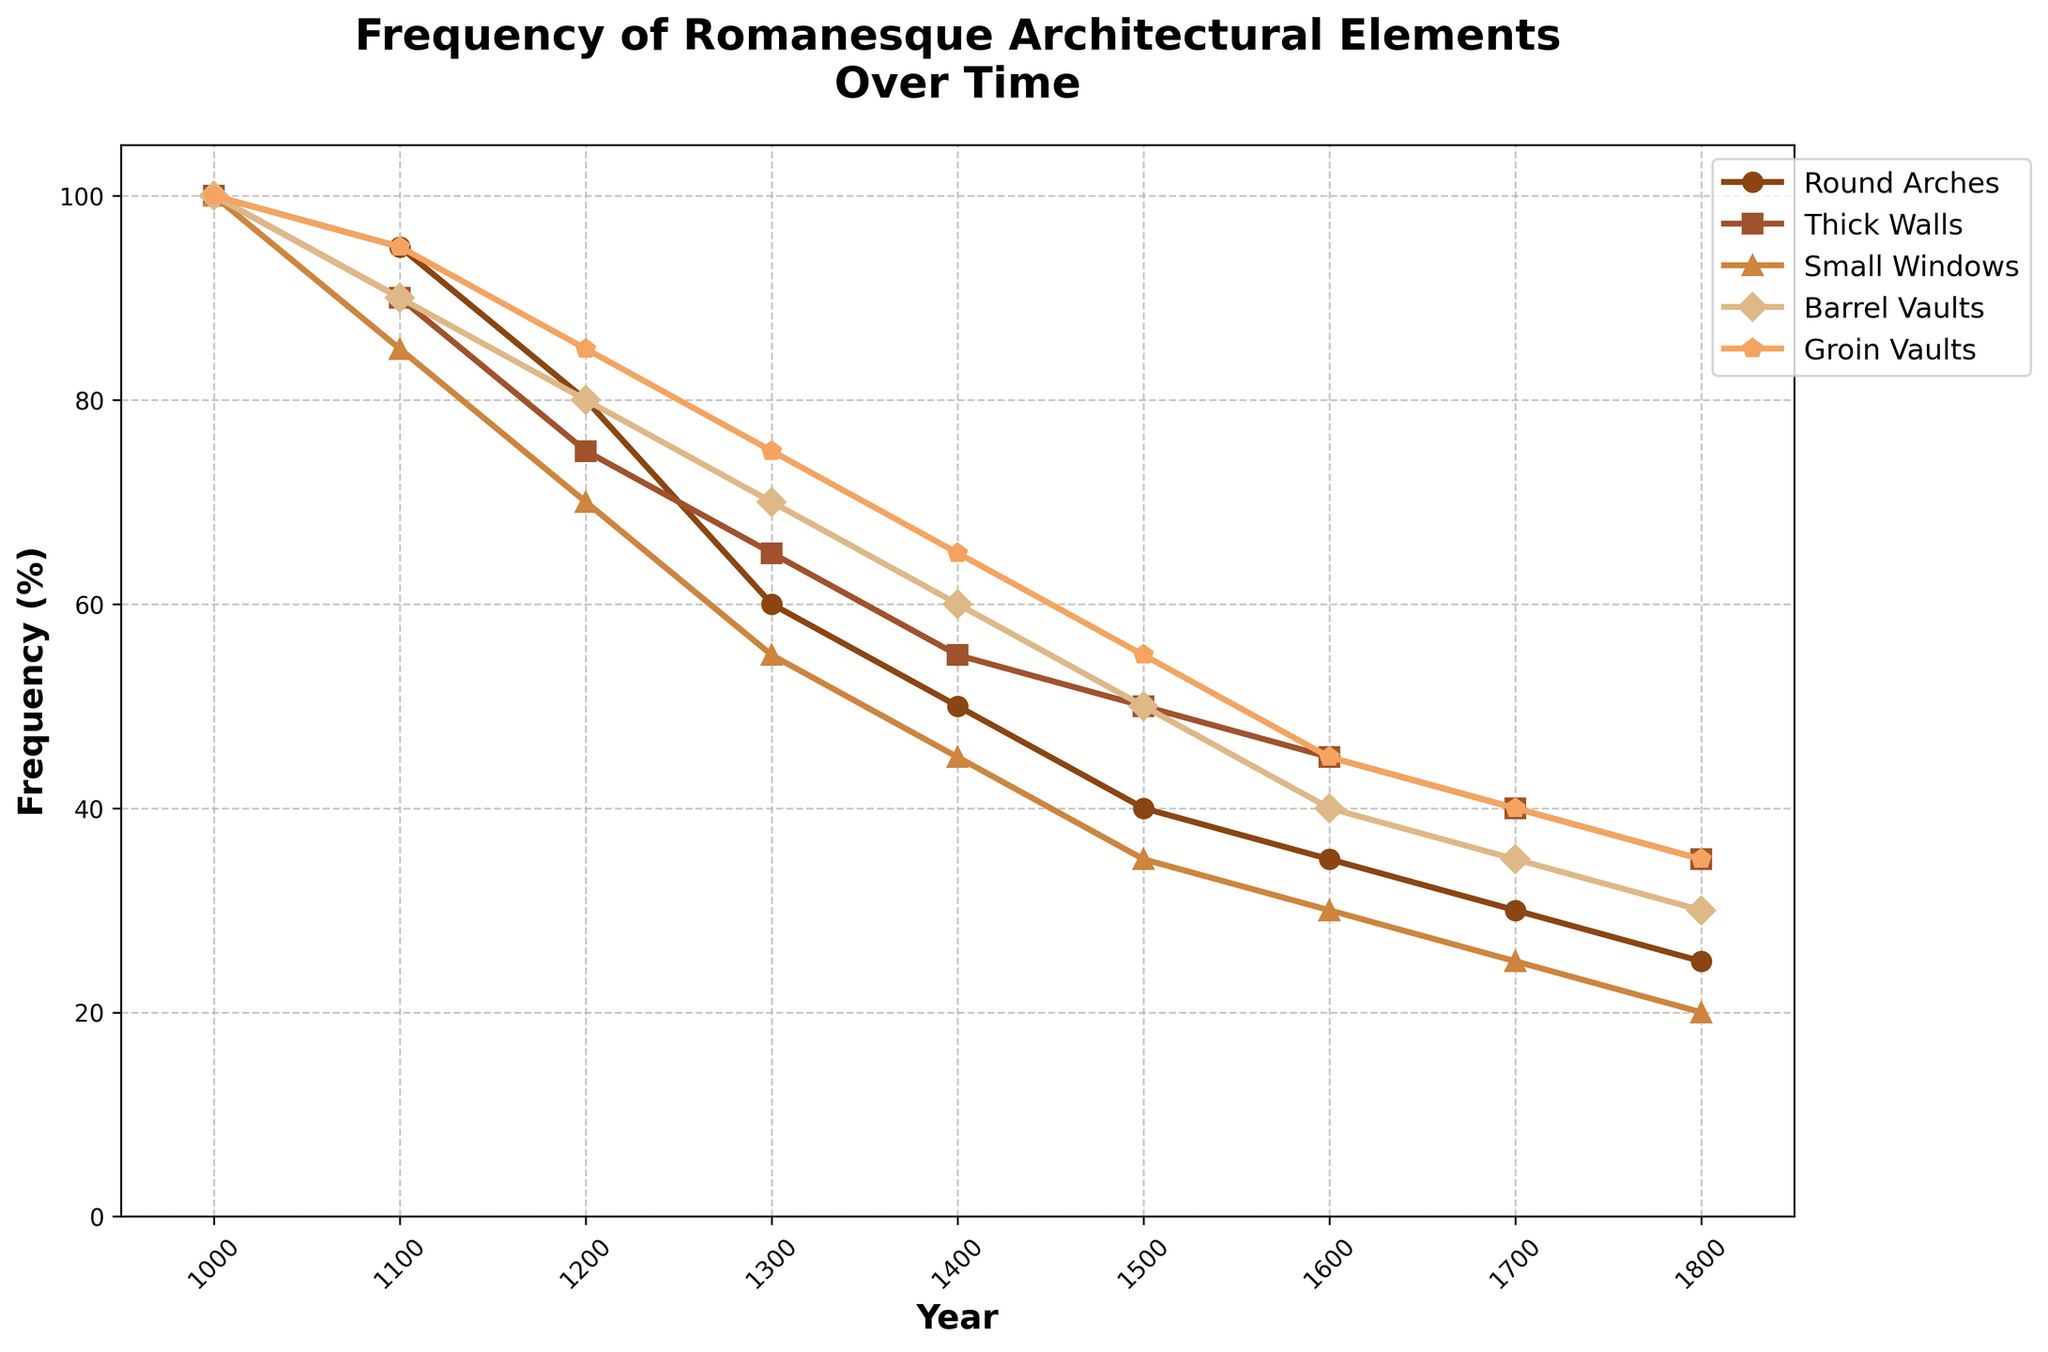What is the trend of the frequency of Round Arches from 1000 AD to 1800 AD? The frequency of Round Arches decreases steadily over time. It starts at 100% in 1000 AD and drops to 25% in 1800 AD, showing a consistent decline.
Answer: Decreasing trend How does the frequency of Thick Walls in 1500 AD compare to its frequency in 1200 AD? In 1500 AD, the frequency of Thick Walls is 50%, and in 1200 AD, it is 75%. 50% is less than 75%, indicating a decrease over time.
Answer: Less Which architectural element retains the highest frequency in 1800 AD? According to the visual representation, Groin Vaults have the highest frequency in 1800 AD at 35%, compared to other elements.
Answer: Groin Vaults Among Round Arches, Thick Walls, and Small Windows, which element shows the greatest percentage drop from 1000 AD to 1400 AD? The frequencies in 1000 AD are all 100%. In 1400 AD, the frequencies are: Round Arches: 50%, Thick Walls: 55%, Small Windows: 45%. Drops: Round Arches: 100-50=50%, Thick Walls: 100-55=45%, Small Windows: 100-45=55%. Greatest drop is for Small Windows.
Answer: Small Windows What is the average frequency of Barrel Vaults and Groin Vaults in 1600 AD? The frequency of Barrel Vaults in 1600 AD is 40% and for Groin Vaults is 45%. Their average is (40+45)/2 = 42.5%.
Answer: 42.5% Which architectural element's frequency drops below 50% first and in which year? Visual inspection shows that Small Windows drop to 45% in 1400 AD, earlier than the other elements, which all remain above 50% at that time.
Answer: Small Windows, 1400 AD Is the frequency of Small Windows ever higher than that of Thick Walls at any point from 1000 AD to 1800 AD? Checking each timestep: initially, both start at 100%. Over time, Thick Walls remain higher than Small Windows through all years from 1000 AD to 1800 AD.
Answer: No By how much does the frequency of Barrel Vaults decrease from 1000 AD to 1700 AD? Barrel Vaults have a frequency of 100% in 1000 AD and 35% in 1700 AD. The decrease is 100% - 35% = 65%.
Answer: 65% Which architectural element shows the most gradual decline from 1000 AD to 1800 AD? Visually comparing all trends, Thick Walls show the most gradual decline, from 100% to 35% over the time period, with less steep drops compared to the other elements.
Answer: Thick Walls 